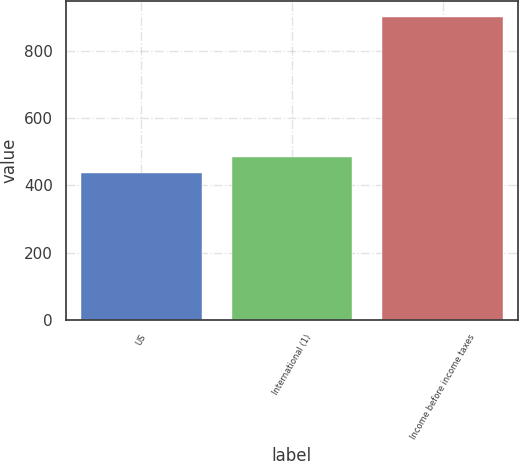Convert chart to OTSL. <chart><loc_0><loc_0><loc_500><loc_500><bar_chart><fcel>US<fcel>International (1)<fcel>Income before income taxes<nl><fcel>436<fcel>482.5<fcel>901<nl></chart> 